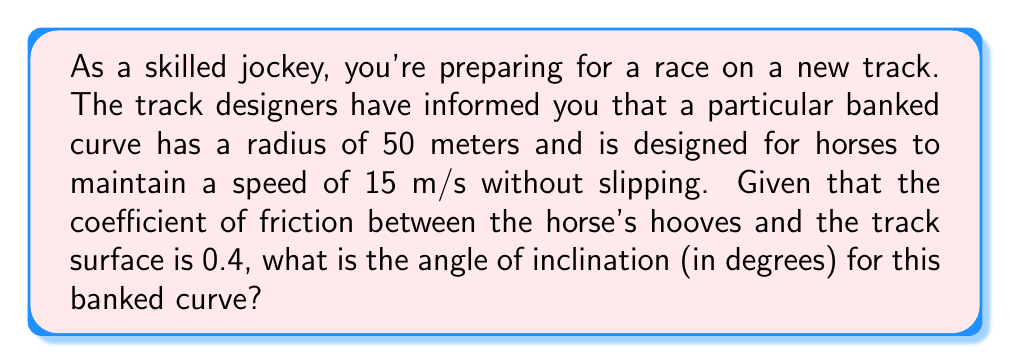Could you help me with this problem? Let's approach this step-by-step:

1) For a banked curve, the angle of inclination ($\theta$) is determined by the balance of forces acting on the horse-jockey system.

2) The formula for the angle of inclination on a banked curve without friction is:

   $$\tan \theta = \frac{v^2}{rg}$$

   Where $v$ is velocity, $r$ is radius, and $g$ is acceleration due to gravity.

3) However, since there is friction, we need to use a modified formula:

   $$\tan \theta = \frac{v^2}{rg} - \mu$$

   Where $\mu$ is the coefficient of friction.

4) Let's substitute the given values:
   $v = 15$ m/s
   $r = 50$ m
   $g = 9.8$ m/s² (standard gravity)
   $\mu = 0.4$

5) Plugging these into our equation:

   $$\tan \theta = \frac{15^2}{50 \cdot 9.8} - 0.4$$

6) Simplify:

   $$\tan \theta = \frac{225}{490} - 0.4 = 0.459 - 0.4 = 0.059$$

7) To find $\theta$, we need to take the inverse tangent (arctan) of both sides:

   $$\theta = \arctan(0.059)$$

8) Using a calculator or computer:

   $$\theta \approx 3.37^\circ$$
Answer: $3.37^\circ$ 